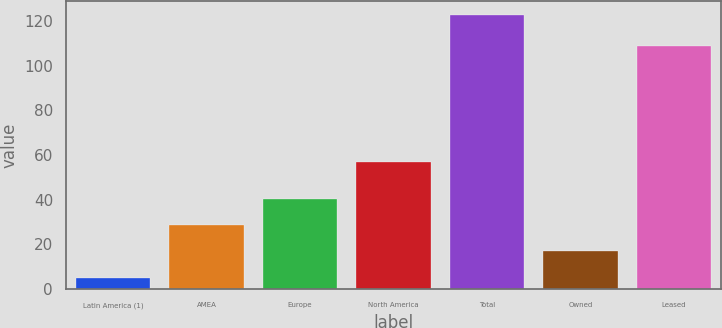Convert chart. <chart><loc_0><loc_0><loc_500><loc_500><bar_chart><fcel>Latin America (1)<fcel>AMEA<fcel>Europe<fcel>North America<fcel>Total<fcel>Owned<fcel>Leased<nl><fcel>5<fcel>28.6<fcel>40.4<fcel>57<fcel>123<fcel>16.8<fcel>109<nl></chart> 